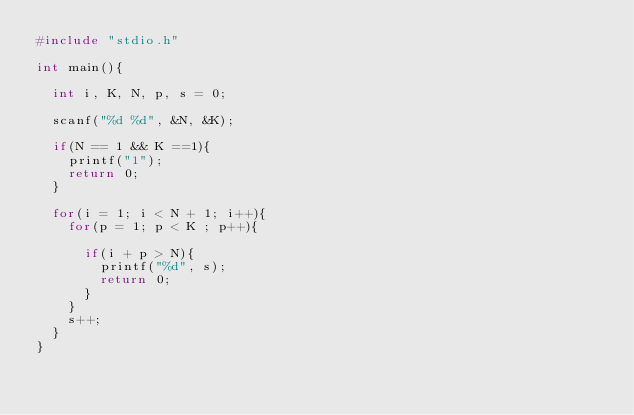Convert code to text. <code><loc_0><loc_0><loc_500><loc_500><_C_>#include "stdio.h"

int main(){

  int i, K, N, p, s = 0;

  scanf("%d %d", &N, &K);

  if(N == 1 && K ==1){
    printf("1");
    return 0;
  }

  for(i = 1; i < N + 1; i++){
    for(p = 1; p < K ; p++){

      if(i + p > N){
        printf("%d", s);
        return 0;
      }
    }
    s++;
  }
}
</code> 